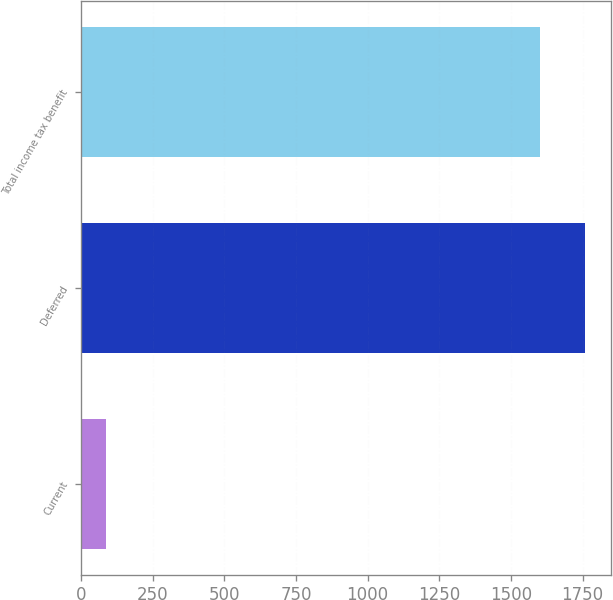Convert chart. <chart><loc_0><loc_0><loc_500><loc_500><bar_chart><fcel>Current<fcel>Deferred<fcel>Total income tax benefit<nl><fcel>88<fcel>1760<fcel>1600<nl></chart> 